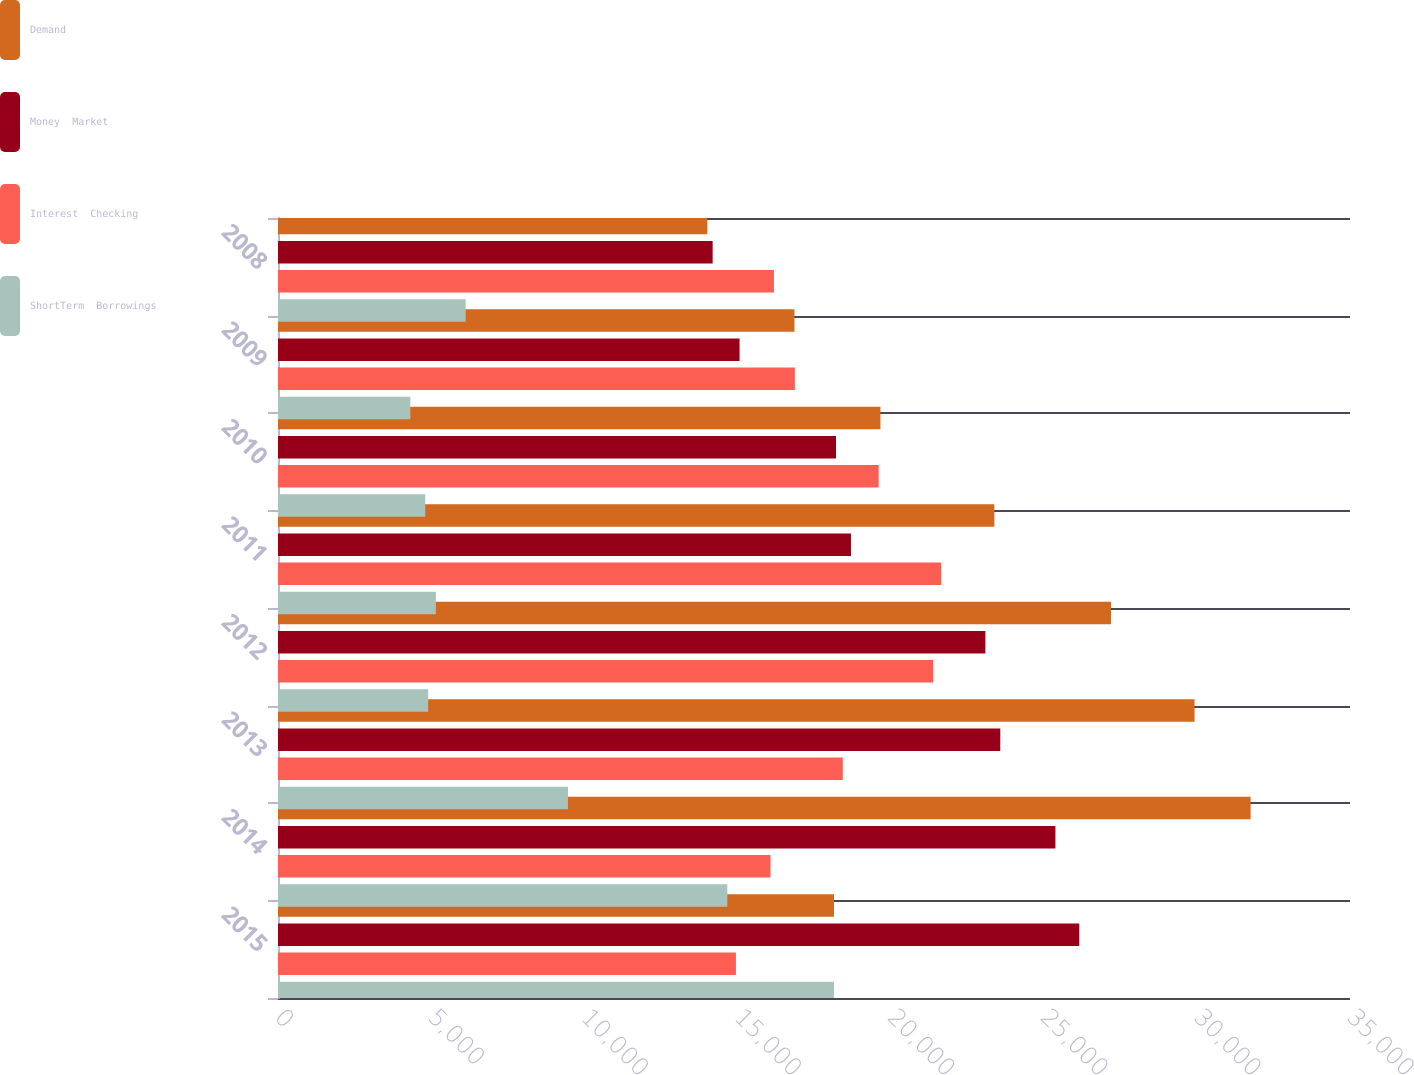<chart> <loc_0><loc_0><loc_500><loc_500><stacked_bar_chart><ecel><fcel>2015<fcel>2014<fcel>2013<fcel>2012<fcel>2011<fcel>2010<fcel>2009<fcel>2008<nl><fcel>Demand<fcel>18152<fcel>31755<fcel>29925<fcel>27196<fcel>23389<fcel>19669<fcel>16862<fcel>14017<nl><fcel>Money  Market<fcel>26160<fcel>25382<fcel>23582<fcel>23096<fcel>18707<fcel>18218<fcel>15070<fcel>14191<nl><fcel>Interest  Checking<fcel>14951<fcel>16080<fcel>18440<fcel>21393<fcel>21652<fcel>19612<fcel>16875<fcel>16192<nl><fcel>ShortTerm  Borrowings<fcel>18152<fcel>14670<fcel>9467<fcel>4903<fcel>5154<fcel>4808<fcel>4320<fcel>6127<nl></chart> 